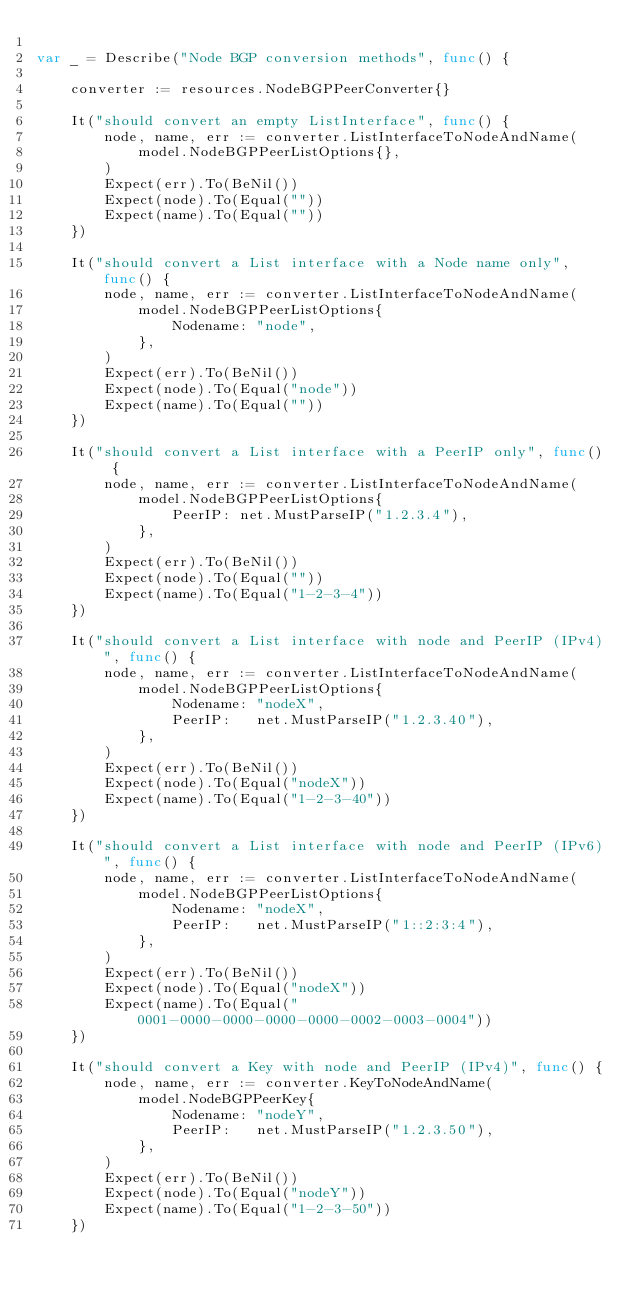Convert code to text. <code><loc_0><loc_0><loc_500><loc_500><_Go_>
var _ = Describe("Node BGP conversion methods", func() {

	converter := resources.NodeBGPPeerConverter{}

	It("should convert an empty ListInterface", func() {
		node, name, err := converter.ListInterfaceToNodeAndName(
			model.NodeBGPPeerListOptions{},
		)
		Expect(err).To(BeNil())
		Expect(node).To(Equal(""))
		Expect(name).To(Equal(""))
	})

	It("should convert a List interface with a Node name only", func() {
		node, name, err := converter.ListInterfaceToNodeAndName(
			model.NodeBGPPeerListOptions{
				Nodename: "node",
			},
		)
		Expect(err).To(BeNil())
		Expect(node).To(Equal("node"))
		Expect(name).To(Equal(""))
	})

	It("should convert a List interface with a PeerIP only", func() {
		node, name, err := converter.ListInterfaceToNodeAndName(
			model.NodeBGPPeerListOptions{
				PeerIP: net.MustParseIP("1.2.3.4"),
			},
		)
		Expect(err).To(BeNil())
		Expect(node).To(Equal(""))
		Expect(name).To(Equal("1-2-3-4"))
	})

	It("should convert a List interface with node and PeerIP (IPv4)", func() {
		node, name, err := converter.ListInterfaceToNodeAndName(
			model.NodeBGPPeerListOptions{
				Nodename: "nodeX",
				PeerIP:   net.MustParseIP("1.2.3.40"),
			},
		)
		Expect(err).To(BeNil())
		Expect(node).To(Equal("nodeX"))
		Expect(name).To(Equal("1-2-3-40"))
	})

	It("should convert a List interface with node and PeerIP (IPv6)", func() {
		node, name, err := converter.ListInterfaceToNodeAndName(
			model.NodeBGPPeerListOptions{
				Nodename: "nodeX",
				PeerIP:   net.MustParseIP("1::2:3:4"),
			},
		)
		Expect(err).To(BeNil())
		Expect(node).To(Equal("nodeX"))
		Expect(name).To(Equal("0001-0000-0000-0000-0000-0002-0003-0004"))
	})

	It("should convert a Key with node and PeerIP (IPv4)", func() {
		node, name, err := converter.KeyToNodeAndName(
			model.NodeBGPPeerKey{
				Nodename: "nodeY",
				PeerIP:   net.MustParseIP("1.2.3.50"),
			},
		)
		Expect(err).To(BeNil())
		Expect(node).To(Equal("nodeY"))
		Expect(name).To(Equal("1-2-3-50"))
	})
</code> 